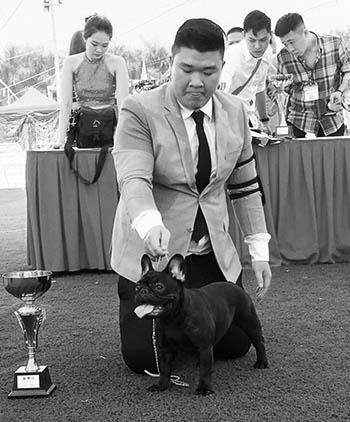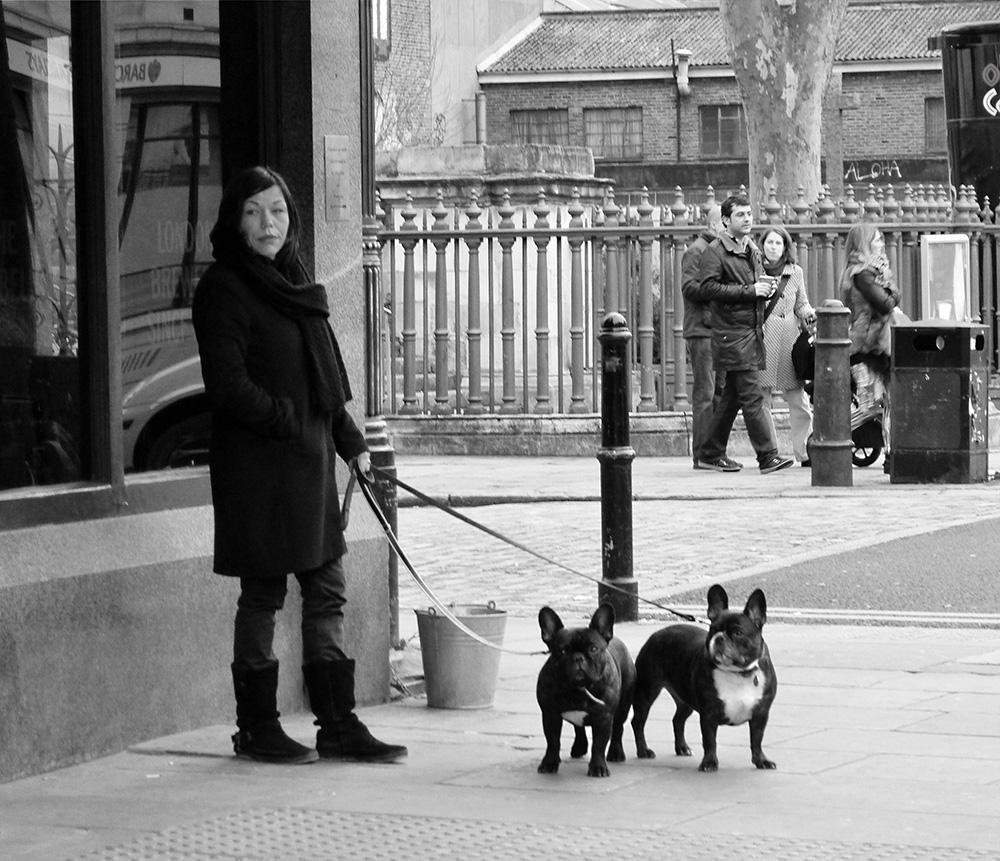The first image is the image on the left, the second image is the image on the right. Examine the images to the left and right. Is the description "A woman is walking multiple dogs on the street." accurate? Answer yes or no. Yes. The first image is the image on the left, the second image is the image on the right. Assess this claim about the two images: "The right image shows a person standing to one side of two black pugs with white chest marks and holding onto a leash.". Correct or not? Answer yes or no. Yes. 